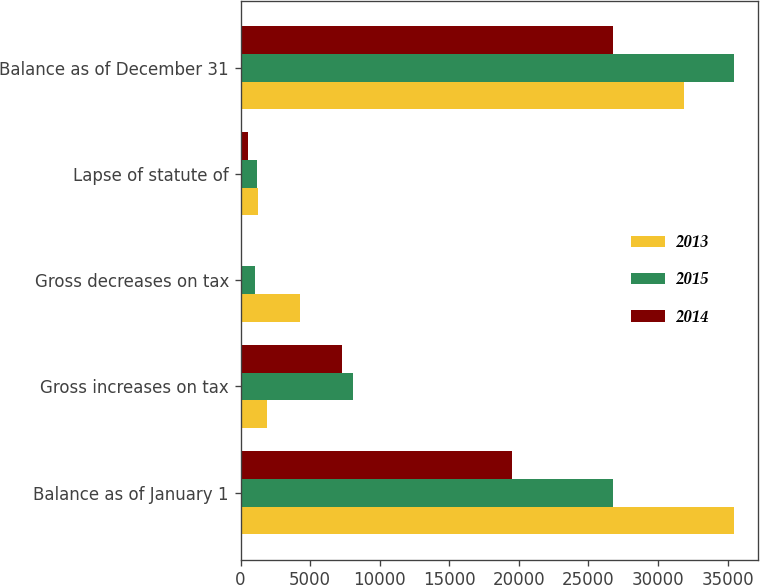<chart> <loc_0><loc_0><loc_500><loc_500><stacked_bar_chart><ecel><fcel>Balance as of January 1<fcel>Gross increases on tax<fcel>Gross decreases on tax<fcel>Lapse of statute of<fcel>Balance as of December 31<nl><fcel>2013<fcel>35429<fcel>1891<fcel>4245<fcel>1242<fcel>31903<nl><fcel>2015<fcel>26745<fcel>8113<fcel>1053<fcel>1204<fcel>35429<nl><fcel>2014<fcel>19493<fcel>7270<fcel>18<fcel>549<fcel>26745<nl></chart> 